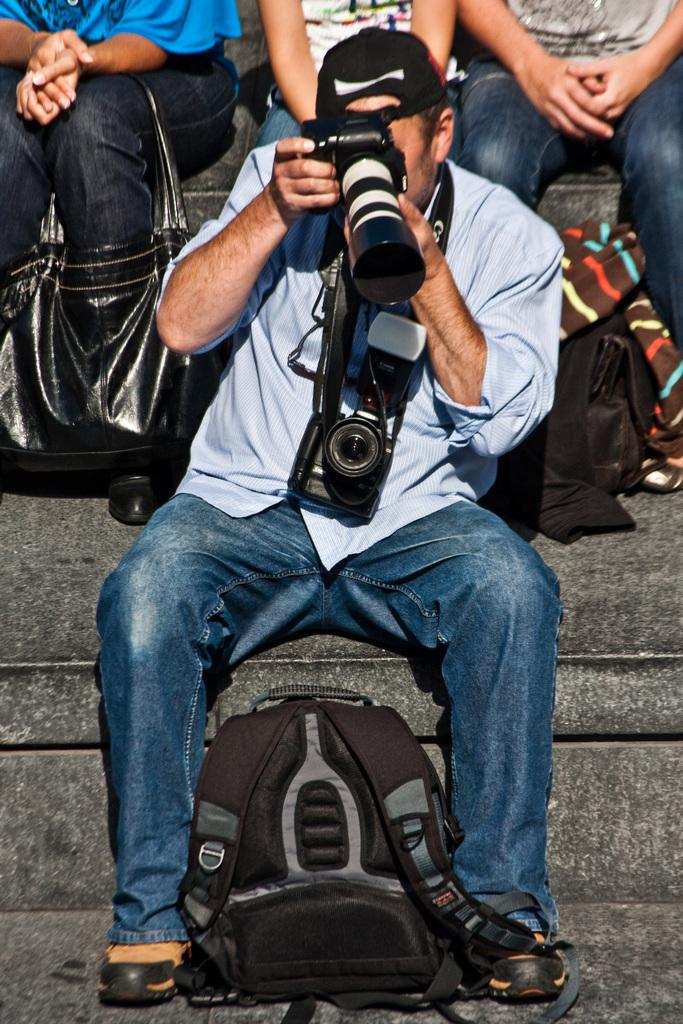Who is present in the image? There is a man in the image. What is the man doing in the image? The man is seated on the stairs. What is the man holding in his hand? The man is holding a camera in his hand. Is there any additional equipment visible in the image? Yes, there is a backpack visible in the image. What type of baseball equipment can be seen in the man's hands? There is no baseball equipment present in the image; the man is holding a camera. How many hands does the man have in the image? The man has two hands in the image, but the number of hands is not relevant to the image's content. 